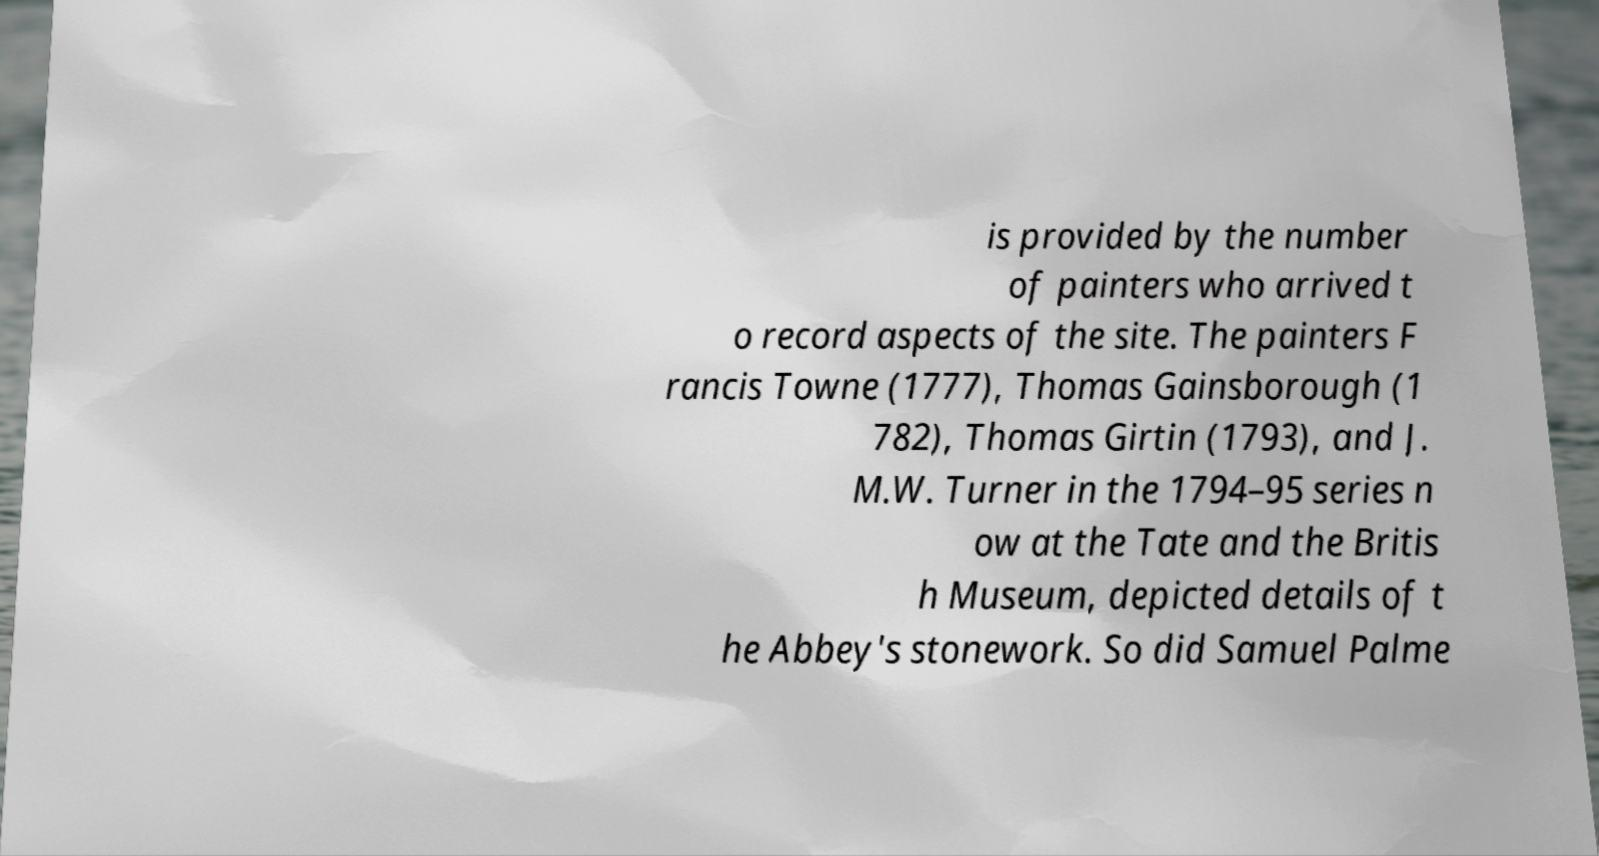Could you assist in decoding the text presented in this image and type it out clearly? is provided by the number of painters who arrived t o record aspects of the site. The painters F rancis Towne (1777), Thomas Gainsborough (1 782), Thomas Girtin (1793), and J. M.W. Turner in the 1794–95 series n ow at the Tate and the Britis h Museum, depicted details of t he Abbey's stonework. So did Samuel Palme 